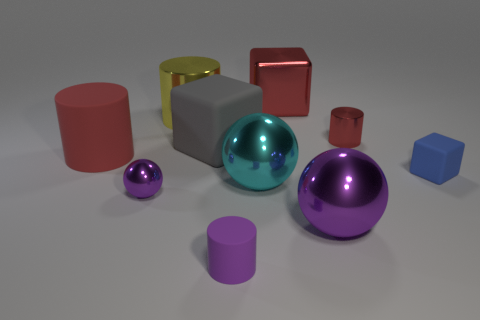There is a purple metal thing right of the small metallic ball; what is its shape?
Your answer should be very brief. Sphere. There is a big cylinder that is left of the purple shiny ball left of the large cube that is to the left of the tiny purple cylinder; what color is it?
Ensure brevity in your answer.  Red. What shape is the large purple object that is made of the same material as the yellow cylinder?
Provide a succinct answer. Sphere. Are there fewer small red spheres than large yellow cylinders?
Your answer should be compact. Yes. Is the material of the tiny purple sphere the same as the cyan sphere?
Provide a short and direct response. Yes. How many other objects are the same color as the metallic cube?
Your answer should be compact. 2. Are there more purple rubber cylinders than green shiny cylinders?
Your answer should be compact. Yes. Do the blue matte block and the red object in front of the small red cylinder have the same size?
Ensure brevity in your answer.  No. What color is the large matte object on the right side of the big red rubber thing?
Provide a succinct answer. Gray. What number of purple objects are either large metal blocks or rubber things?
Give a very brief answer. 1. 